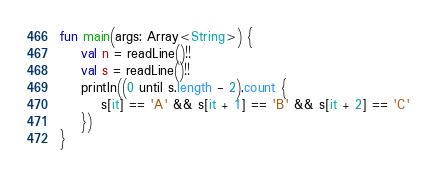<code> <loc_0><loc_0><loc_500><loc_500><_Kotlin_>fun main(args: Array<String>) {
    val n = readLine()!!
    val s = readLine()!!
    println((0 until s.length - 2).count {
        s[it] == 'A' && s[it + 1] == 'B' && s[it + 2] == 'C'
    })
}</code> 